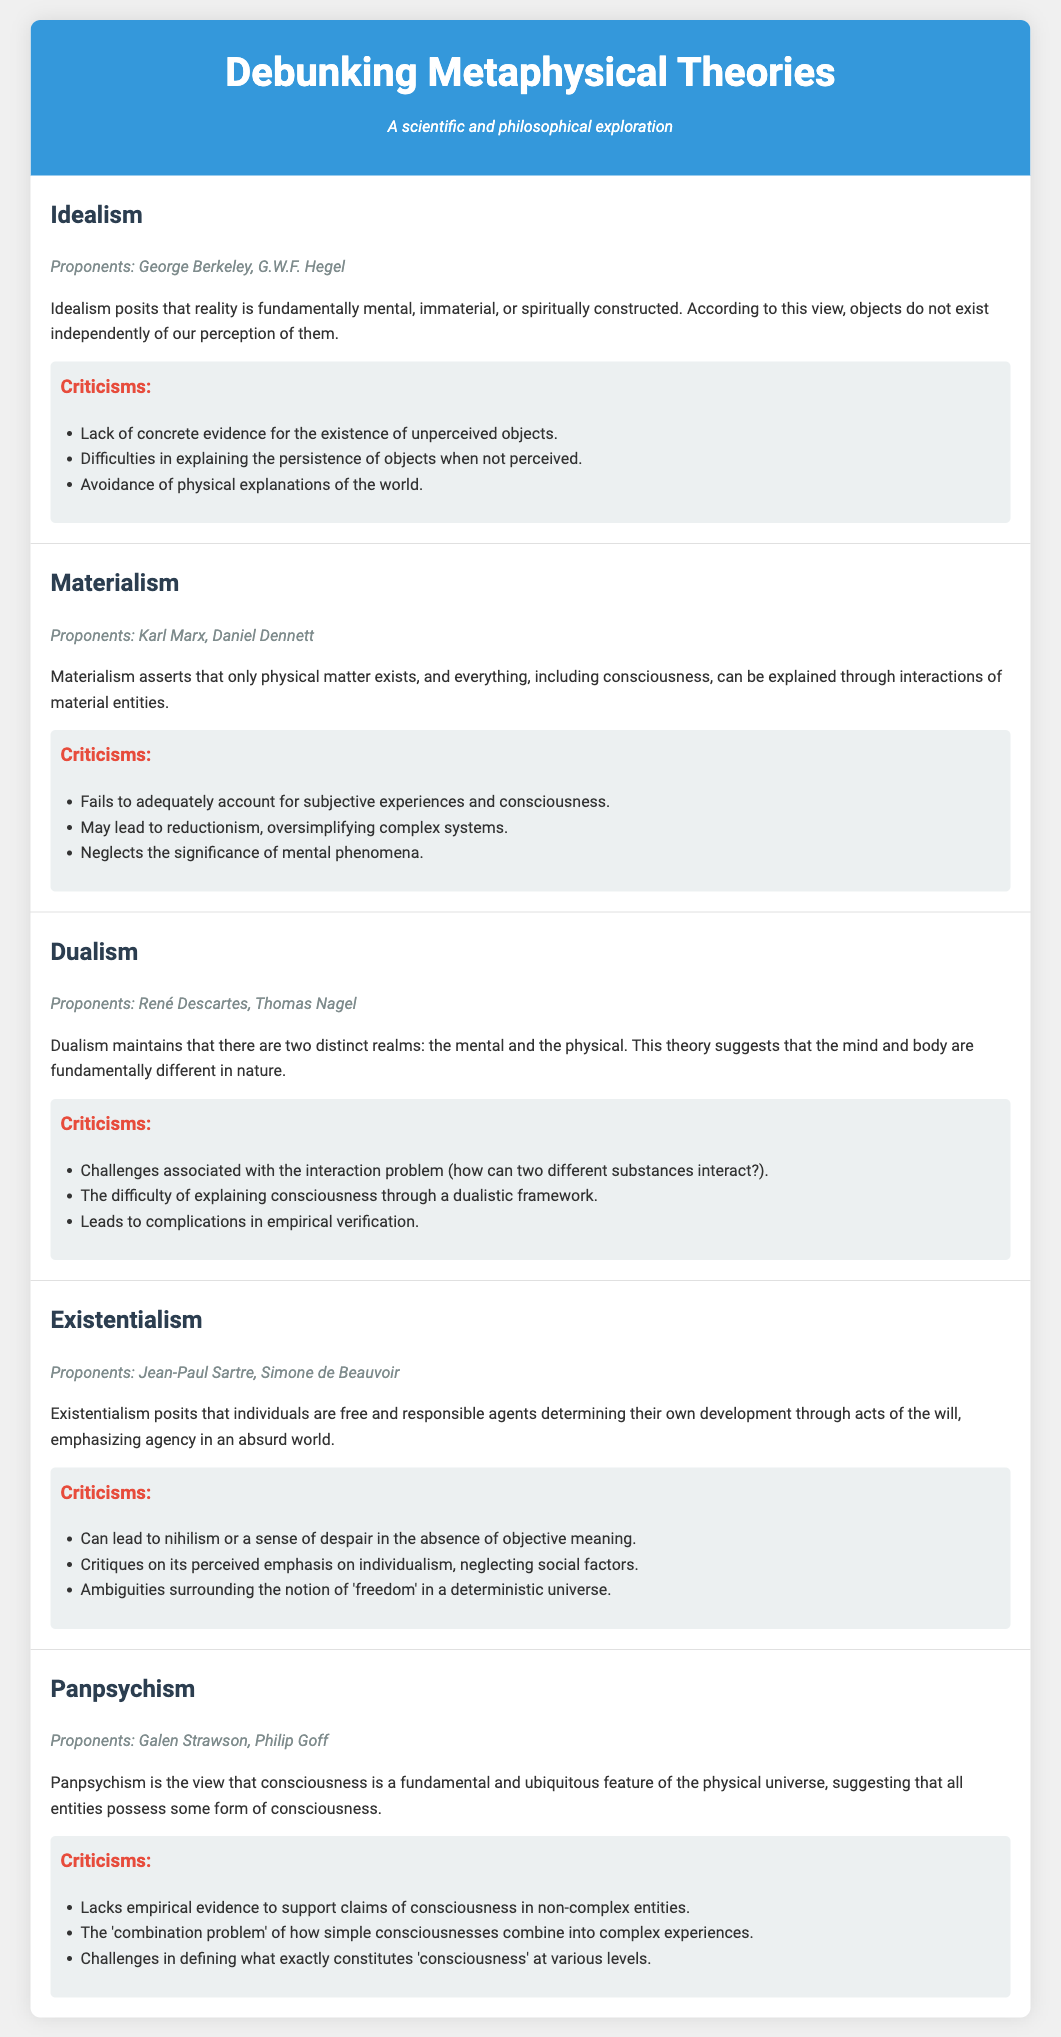What is the main claim of Idealism? Idealism posits that reality is fundamentally mental, immaterial, or spiritually constructed, indicating that objects do not exist independently of our perception of them.
Answer: Reality is fundamentally mental Who are the proponents of Materialism? The proponents of Materialism listed in the document are Karl Marx and Daniel Dennett.
Answer: Karl Marx, Daniel Dennett What is a criticism of Dualism related to interaction? One key criticism highlights challenges associated with the interaction problem, questioning how two different substances can interact.
Answer: Interaction problem Which metaphysical theory emphasizes agency in an absurd world? Existentialism posits that individuals are free and responsible agents determining their own development.
Answer: Existentialism What is a common critique of Panpsychism? A significant critique is the lack of empirical evidence to support claims of consciousness in non-complex entities.
Answer: Lack of empirical evidence How many theories are compared in the document? The document discusses a total of five metaphysical theories.
Answer: Five 